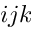Convert formula to latex. <formula><loc_0><loc_0><loc_500><loc_500>i j k</formula> 